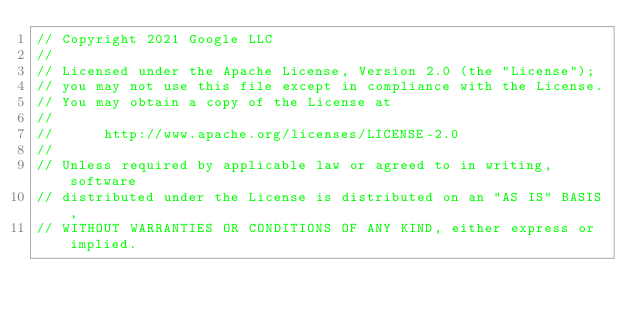Convert code to text. <code><loc_0><loc_0><loc_500><loc_500><_Go_>// Copyright 2021 Google LLC
//
// Licensed under the Apache License, Version 2.0 (the "License");
// you may not use this file except in compliance with the License.
// You may obtain a copy of the License at
//
//      http://www.apache.org/licenses/LICENSE-2.0
//
// Unless required by applicable law or agreed to in writing, software
// distributed under the License is distributed on an "AS IS" BASIS,
// WITHOUT WARRANTIES OR CONDITIONS OF ANY KIND, either express or implied.</code> 